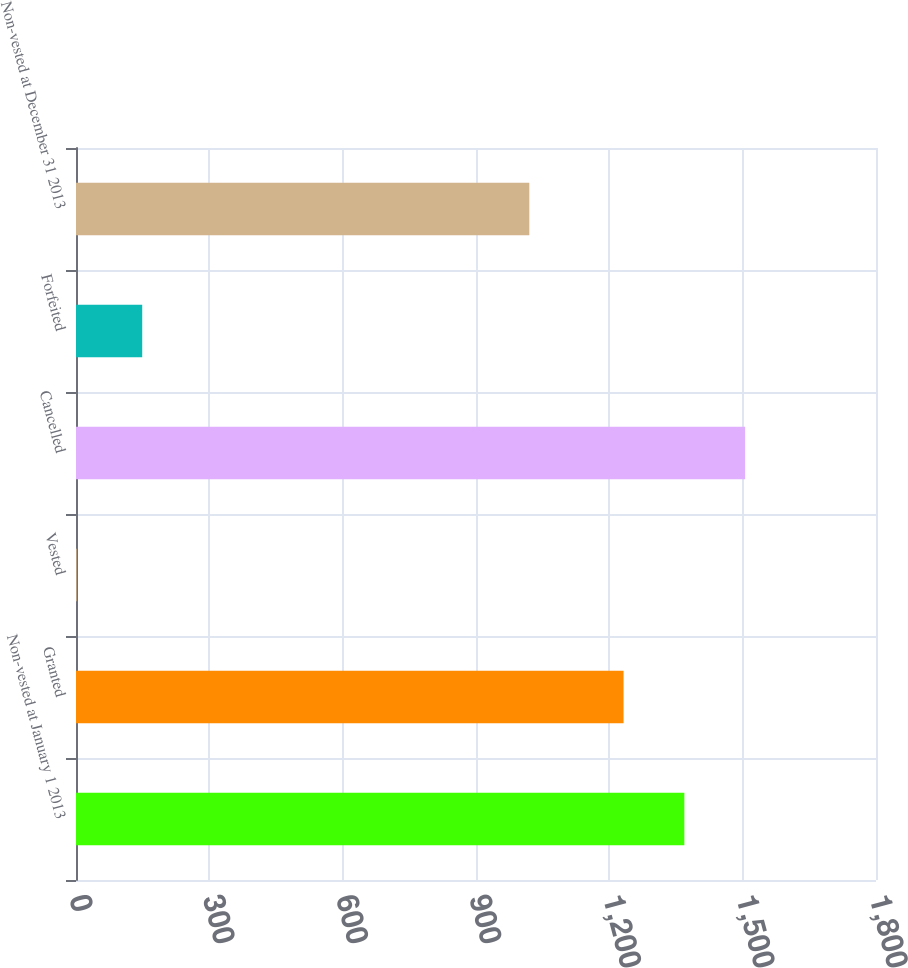Convert chart to OTSL. <chart><loc_0><loc_0><loc_500><loc_500><bar_chart><fcel>Non-vested at January 1 2013<fcel>Granted<fcel>Vested<fcel>Cancelled<fcel>Forfeited<fcel>Non-vested at December 31 2013<nl><fcel>1368.76<fcel>1232<fcel>1.45<fcel>1505.51<fcel>149<fcel>1020<nl></chart> 